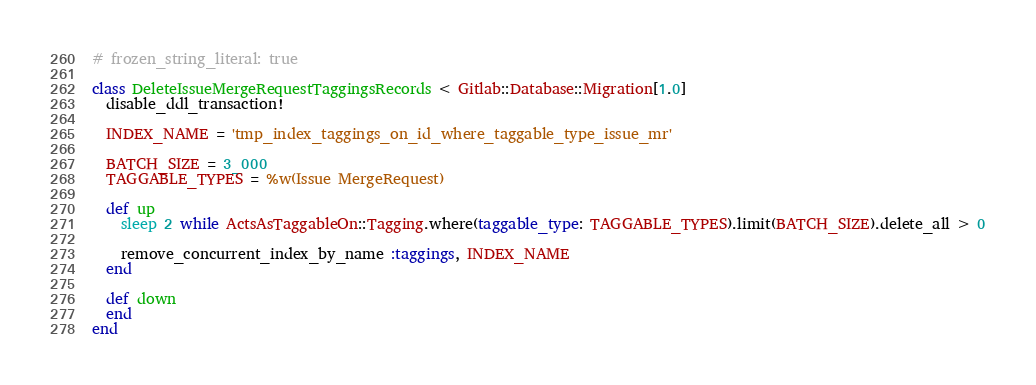Convert code to text. <code><loc_0><loc_0><loc_500><loc_500><_Ruby_># frozen_string_literal: true

class DeleteIssueMergeRequestTaggingsRecords < Gitlab::Database::Migration[1.0]
  disable_ddl_transaction!

  INDEX_NAME = 'tmp_index_taggings_on_id_where_taggable_type_issue_mr'

  BATCH_SIZE = 3_000
  TAGGABLE_TYPES = %w(Issue MergeRequest)

  def up
    sleep 2 while ActsAsTaggableOn::Tagging.where(taggable_type: TAGGABLE_TYPES).limit(BATCH_SIZE).delete_all > 0

    remove_concurrent_index_by_name :taggings, INDEX_NAME
  end

  def down
  end
end
</code> 